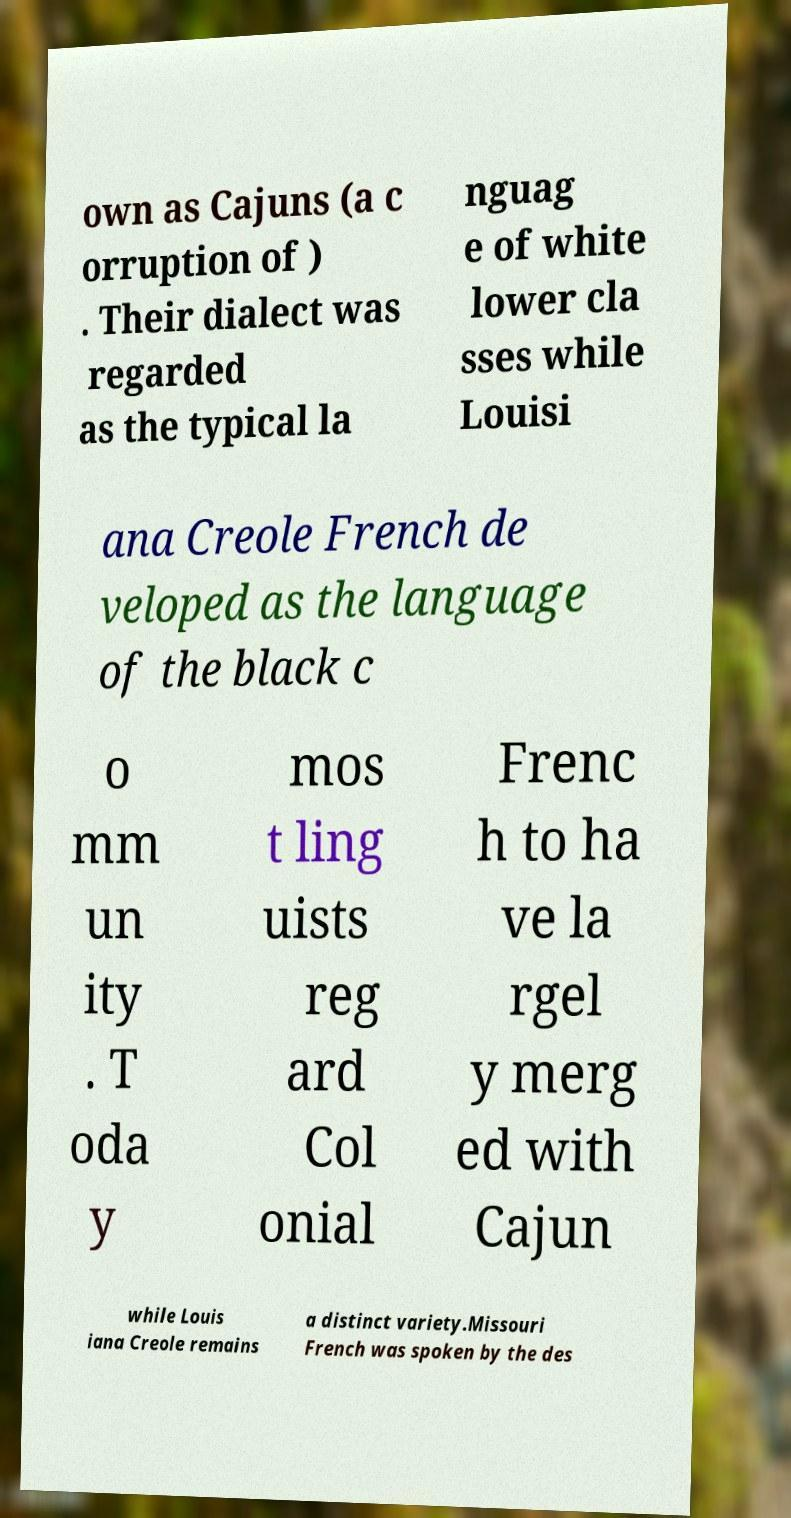Can you accurately transcribe the text from the provided image for me? own as Cajuns (a c orruption of ) . Their dialect was regarded as the typical la nguag e of white lower cla sses while Louisi ana Creole French de veloped as the language of the black c o mm un ity . T oda y mos t ling uists reg ard Col onial Frenc h to ha ve la rgel y merg ed with Cajun while Louis iana Creole remains a distinct variety.Missouri French was spoken by the des 